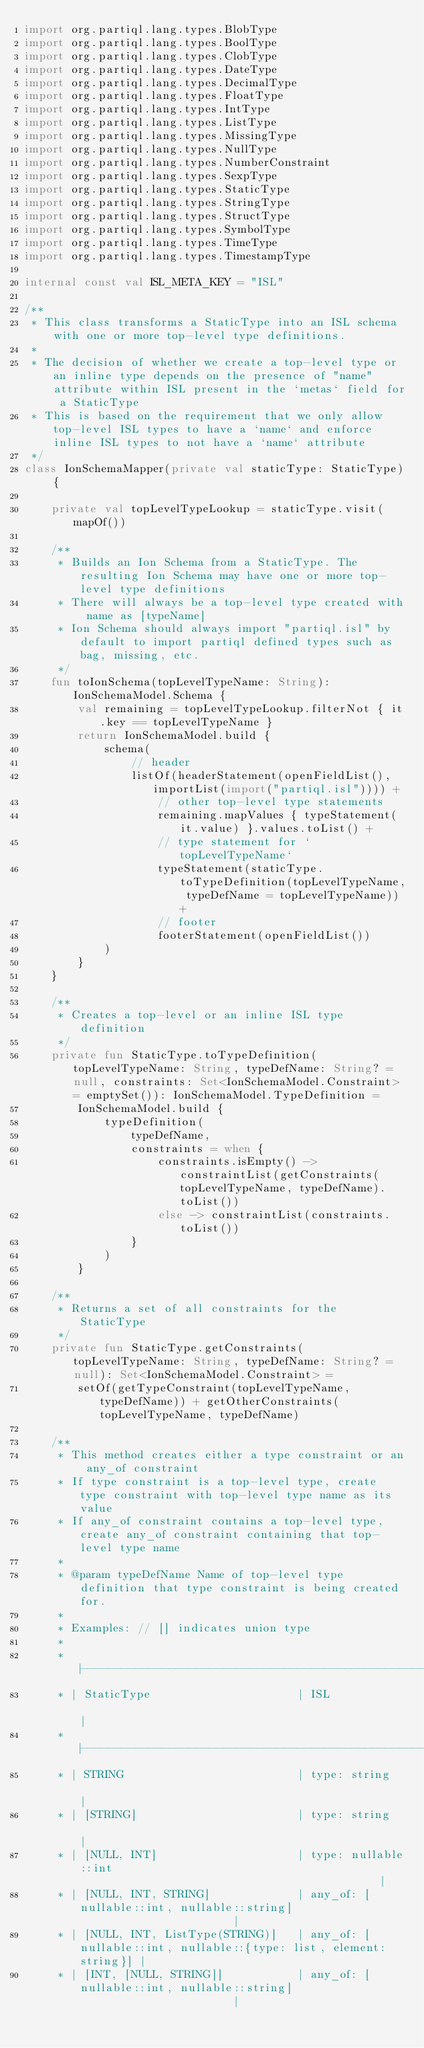<code> <loc_0><loc_0><loc_500><loc_500><_Kotlin_>import org.partiql.lang.types.BlobType
import org.partiql.lang.types.BoolType
import org.partiql.lang.types.ClobType
import org.partiql.lang.types.DateType
import org.partiql.lang.types.DecimalType
import org.partiql.lang.types.FloatType
import org.partiql.lang.types.IntType
import org.partiql.lang.types.ListType
import org.partiql.lang.types.MissingType
import org.partiql.lang.types.NullType
import org.partiql.lang.types.NumberConstraint
import org.partiql.lang.types.SexpType
import org.partiql.lang.types.StaticType
import org.partiql.lang.types.StringType
import org.partiql.lang.types.StructType
import org.partiql.lang.types.SymbolType
import org.partiql.lang.types.TimeType
import org.partiql.lang.types.TimestampType

internal const val ISL_META_KEY = "ISL"

/**
 * This class transforms a StaticType into an ISL schema with one or more top-level type definitions.
 *
 * The decision of whether we create a top-level type or an inline type depends on the presence of "name" attribute within ISL present in the `metas` field for a StaticType
 * This is based on the requirement that we only allow top-level ISL types to have a `name` and enforce inline ISL types to not have a `name` attribute
 */
class IonSchemaMapper(private val staticType: StaticType) {

    private val topLevelTypeLookup = staticType.visit(mapOf())

    /**
     * Builds an Ion Schema from a StaticType. The resulting Ion Schema may have one or more top-level type definitions
     * There will always be a top-level type created with name as [typeName]
     * Ion Schema should always import "partiql.isl" by default to import partiql defined types such as bag, missing, etc.
     */
    fun toIonSchema(topLevelTypeName: String): IonSchemaModel.Schema {
        val remaining = topLevelTypeLookup.filterNot { it.key == topLevelTypeName }
        return IonSchemaModel.build {
            schema(
                // header
                listOf(headerStatement(openFieldList(), importList(import("partiql.isl")))) +
                    // other top-level type statements
                    remaining.mapValues { typeStatement(it.value) }.values.toList() +
                    // type statement for `topLevelTypeName`
                    typeStatement(staticType.toTypeDefinition(topLevelTypeName, typeDefName = topLevelTypeName)) +
                    // footer
                    footerStatement(openFieldList())
            )
        }
    }

    /**
     * Creates a top-level or an inline ISL type definition
     */
    private fun StaticType.toTypeDefinition(topLevelTypeName: String, typeDefName: String? = null, constraints: Set<IonSchemaModel.Constraint> = emptySet()): IonSchemaModel.TypeDefinition =
        IonSchemaModel.build {
            typeDefinition(
                typeDefName,
                constraints = when {
                    constraints.isEmpty() -> constraintList(getConstraints(topLevelTypeName, typeDefName).toList())
                    else -> constraintList(constraints.toList())
                }
            )
        }

    /**
     * Returns a set of all constraints for the StaticType
     */
    private fun StaticType.getConstraints(topLevelTypeName: String, typeDefName: String? = null): Set<IonSchemaModel.Constraint> =
        setOf(getTypeConstraint(topLevelTypeName, typeDefName)) + getOtherConstraints(topLevelTypeName, typeDefName)

    /**
     * This method creates either a type constraint or an any_of constraint
     * If type constraint is a top-level type, create type constraint with top-level type name as its value
     * If any_of constraint contains a top-level type, create any_of constraint containing that top-level type name
     *
     * @param typeDefName Name of top-level type definition that type constraint is being created for.
     *
     * Examples: // [] indicates union type
     *
     * |----------------------------------------------------------------------------------------------------|
     * | StaticType                      | ISL                                                              |
     * |----------------------------------------------------------------------------------------------------|
     * | STRING                          | type: string                                                     |
     * | [STRING]                        | type: string                                                     |
     * | [NULL, INT]                     | type: nullable::int                                              |
     * | [NULL, INT, STRING]             | any_of: [nullable::int, nullable::string]                        |
     * | [NULL, INT, ListType(STRING)]   | any_of: [nullable::int, nullable::{type: list, element: string}] |
     * | [INT, [NULL, STRING]]           | any_of: [nullable::int, nullable::string]                        |</code> 